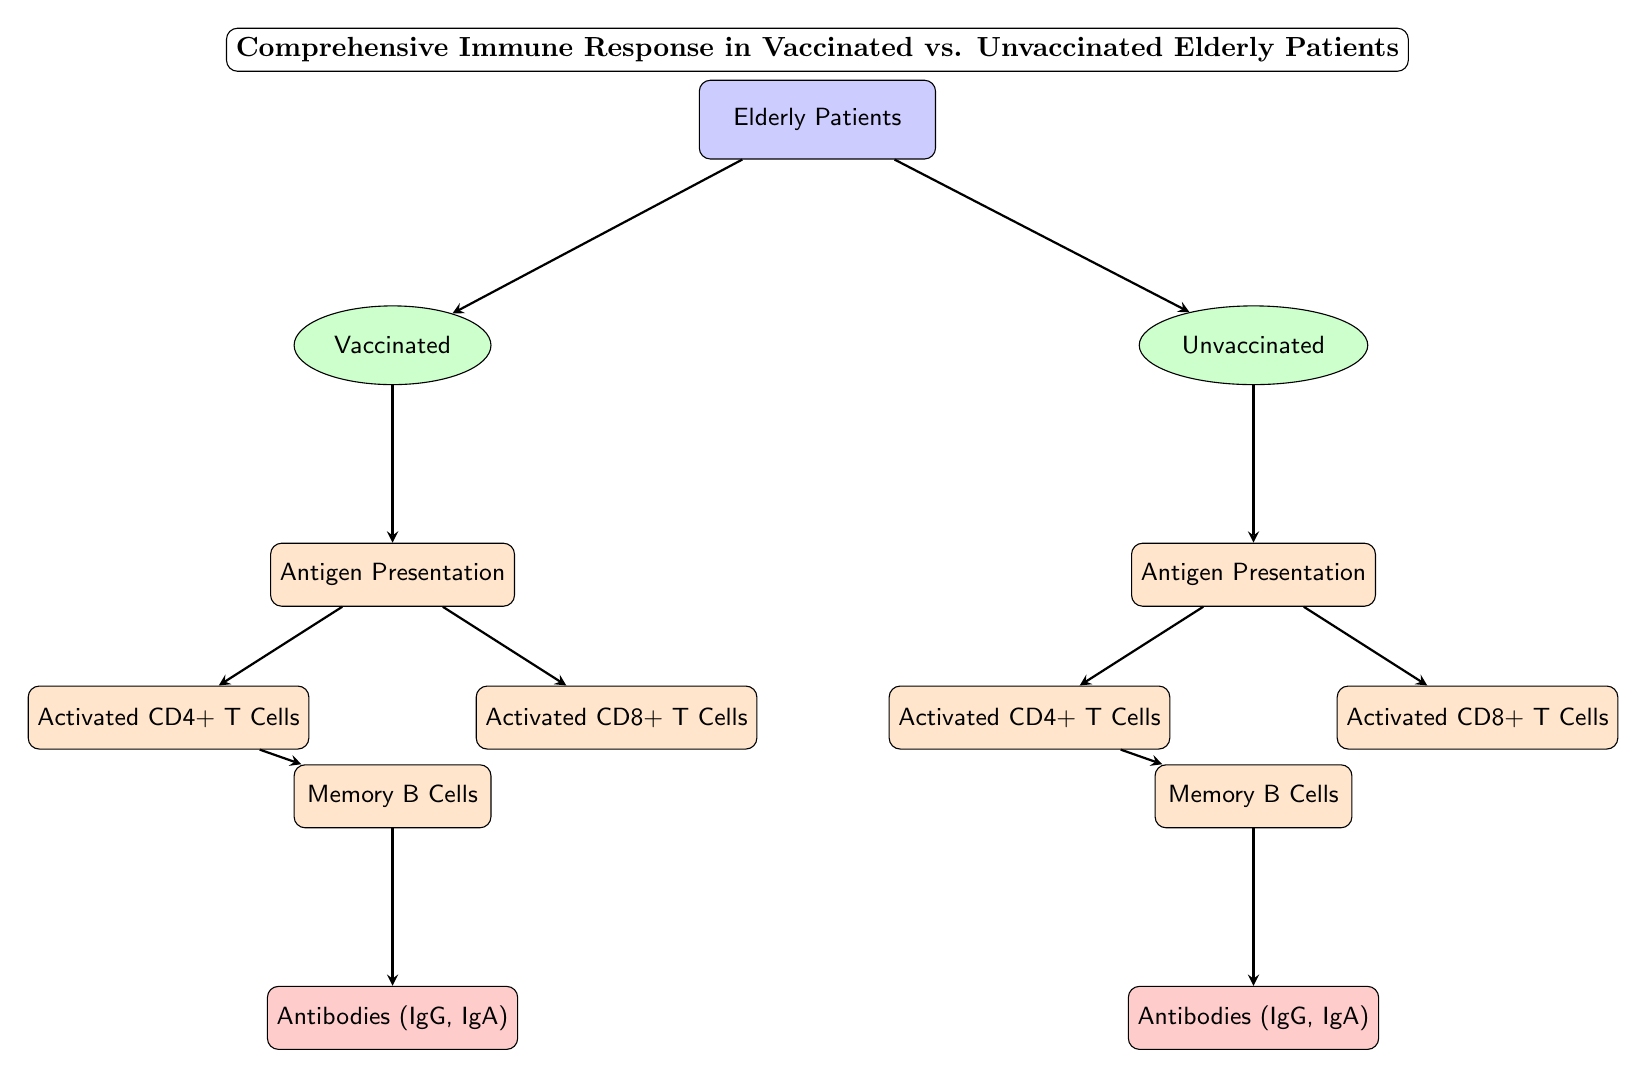What are the two groups of elderly patients in the diagram? The diagram depicts two groups of elderly patients: one group consists of vaccinated patients, and the other consists of unvaccinated patients. These groups are clearly labeled in the diagram.
Answer: Vaccinated and Unvaccinated How many processes follow antigen presentation in vaccinated patients? In the diagram, after antigen presentation for vaccinated patients, there are two processes: Activated CD4+ T Cells and Activated CD8+ T Cells. This can be visually confirmed by counting the nodes connected below the antigen presentation node for the vaccinated group.
Answer: 2 What immune cell types are activated in unvaccinated patients? The immune cell types activated in unvaccinated patients, as shown in the diagram, are Activated CD4+ T Cells and Activated CD8+ T Cells. Both cell types are depicted as processes branching from the antigen presentation node for unvaccinated patients.
Answer: Activated CD4+ T Cells and Activated CD8+ T Cells What is produced after memory B cells in vaccinated patients? The diagram indicates that after memory B cells in vaccinated patients, Antibodies (IgG, IgA) are produced. The flow of information from memory B cells leads directly to this outcome, clearly represented at the end of the flow for vaccinated patients.
Answer: Antibodies (IgG, IgA) What is the primary difference in immune response progression between vaccinated and unvaccinated elderly patients? The primary difference in immune response progression is that vaccinated patients have a more structured pathway leading to memory B cells and the production of antibodies compared to unvaccinated patients, who may not progress to the same extent or efficiency in generating antibodies after antigen presentation. This is inferred from the distinct flow and final outcomes depicted for each group.
Answer: Structured pathway vs. Less structured pathway How does the process of CD4+ T cell activation differ between the two patient groups? In the diagram, the activation of CD4+ T cells occurs after the antigen presentation in both groups. However, for vaccinated patients, this process is followed by the development of memory B cells and the production of antibodies, indicating a more effective immune response. In contrast, the unvaccinated patients' pathway leads to memory B cells too but may not result in the same level of antibody production. Thus, the main difference lies in the efficiency and outcome of the response post-activation.
Answer: Efficiency and outcome differ 